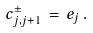Convert formula to latex. <formula><loc_0><loc_0><loc_500><loc_500>c ^ { \pm } _ { j , j + 1 } \, = \, e _ { j } \, .</formula> 